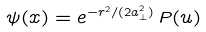<formula> <loc_0><loc_0><loc_500><loc_500>\psi ( x ) = e ^ { - r ^ { 2 } / ( 2 a _ { \bot } ^ { 2 } ) } \, P ( u )</formula> 